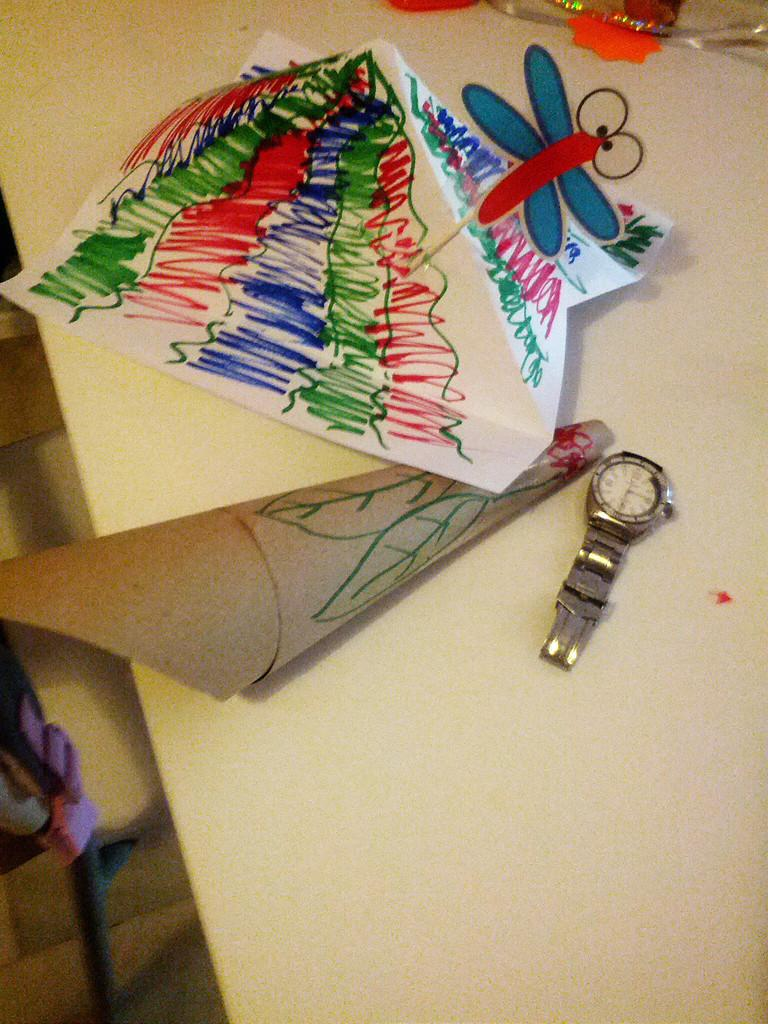What piece of furniture is present in the image? There is a table in the image. What object related to timekeeping is on the table? There is a watch on the table. What type of objects made of paper can be seen on the table? There are paper objects on the table. What type of rake is being used to gather attention in the image? There is no rake present in the image, and no object is being used to gather attention. 